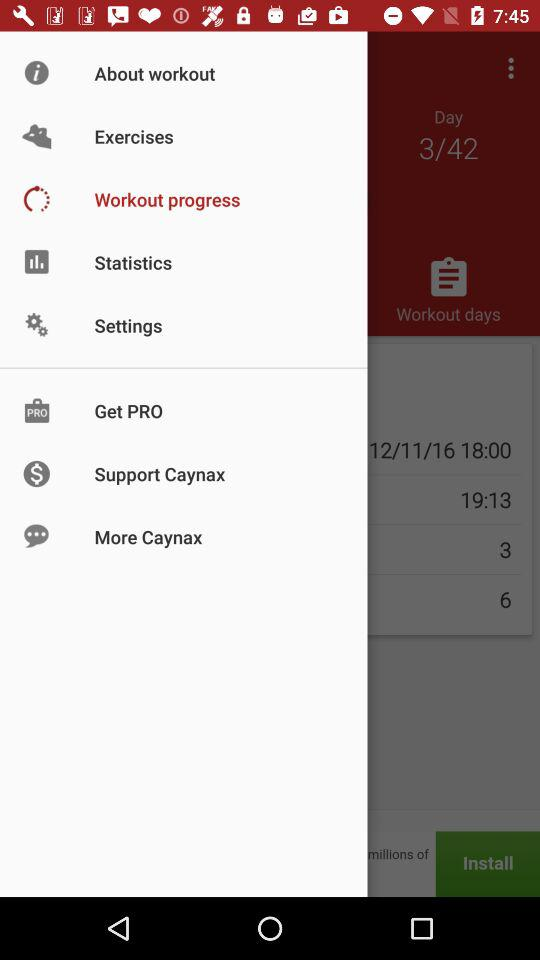Which option has been selected? The selected option is "Workout progress". 